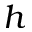<formula> <loc_0><loc_0><loc_500><loc_500>h</formula> 